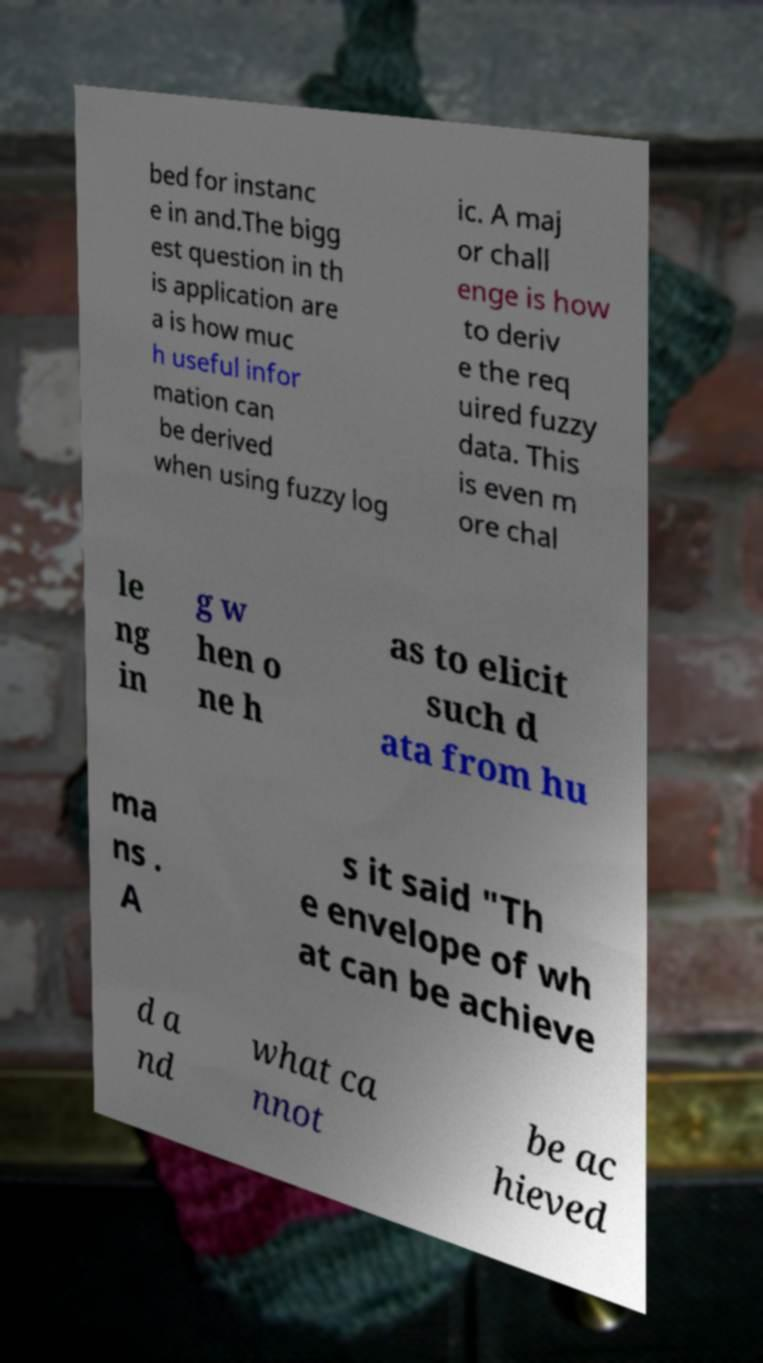There's text embedded in this image that I need extracted. Can you transcribe it verbatim? bed for instanc e in and.The bigg est question in th is application are a is how muc h useful infor mation can be derived when using fuzzy log ic. A maj or chall enge is how to deriv e the req uired fuzzy data. This is even m ore chal le ng in g w hen o ne h as to elicit such d ata from hu ma ns . A s it said "Th e envelope of wh at can be achieve d a nd what ca nnot be ac hieved 